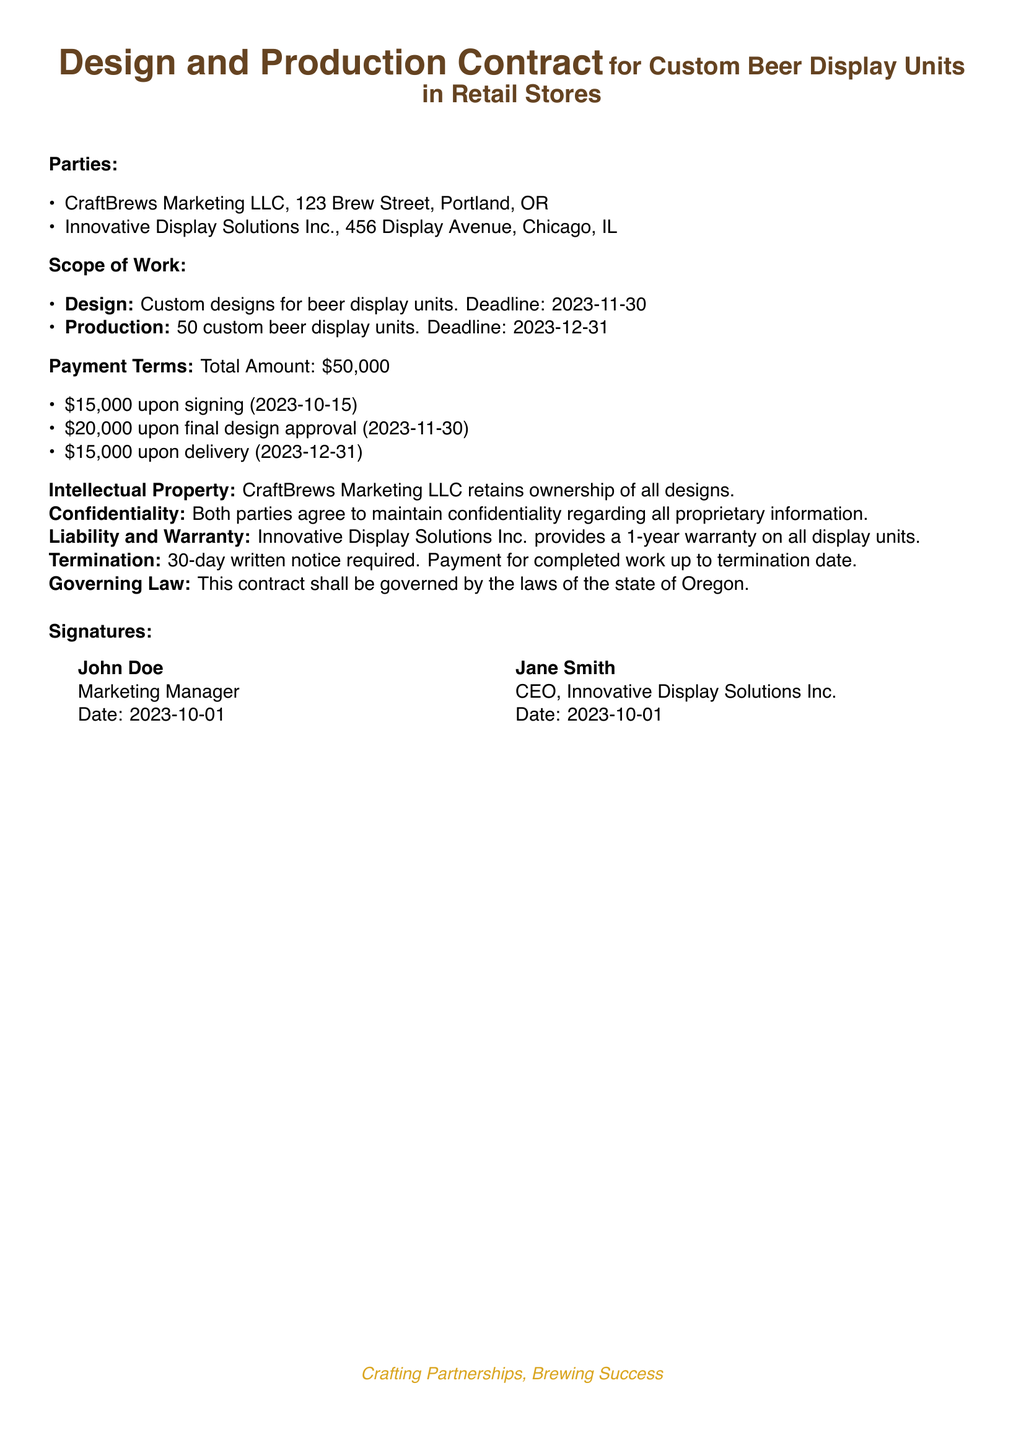What is the total payment amount? The total payment amount is specified in the document under Payment Terms, totaling $50,000.
Answer: $50,000 Who is the CEO of Innovative Display Solutions Inc.? The document lists the CEO of Innovative Display Solutions Inc. as Jane Smith.
Answer: Jane Smith What is the deadline for design completion? The deadline for the design, mentioned in the Scope of Work, is 2023-11-30.
Answer: 2023-11-30 How many display units are to be produced? The Scope of Work states that 50 custom beer display units are to be produced.
Answer: 50 What warranty period is provided for the display units? The contract specifies that there is a 1-year warranty on all display units provided by Innovative Display Solutions Inc.
Answer: 1-year What must be provided for termination of the contract? The document states that a 30-day written notice is required for termination of the contract.
Answer: 30-day written notice Who retains ownership of the designs? According to the Intellectual Property section, CraftBrews Marketing LLC retains ownership of all designs.
Answer: CraftBrews Marketing LLC When is the final payment due? The final payment of $15,000 is due upon delivery, which is specified in the Payment Terms.
Answer: 2023-12-31 